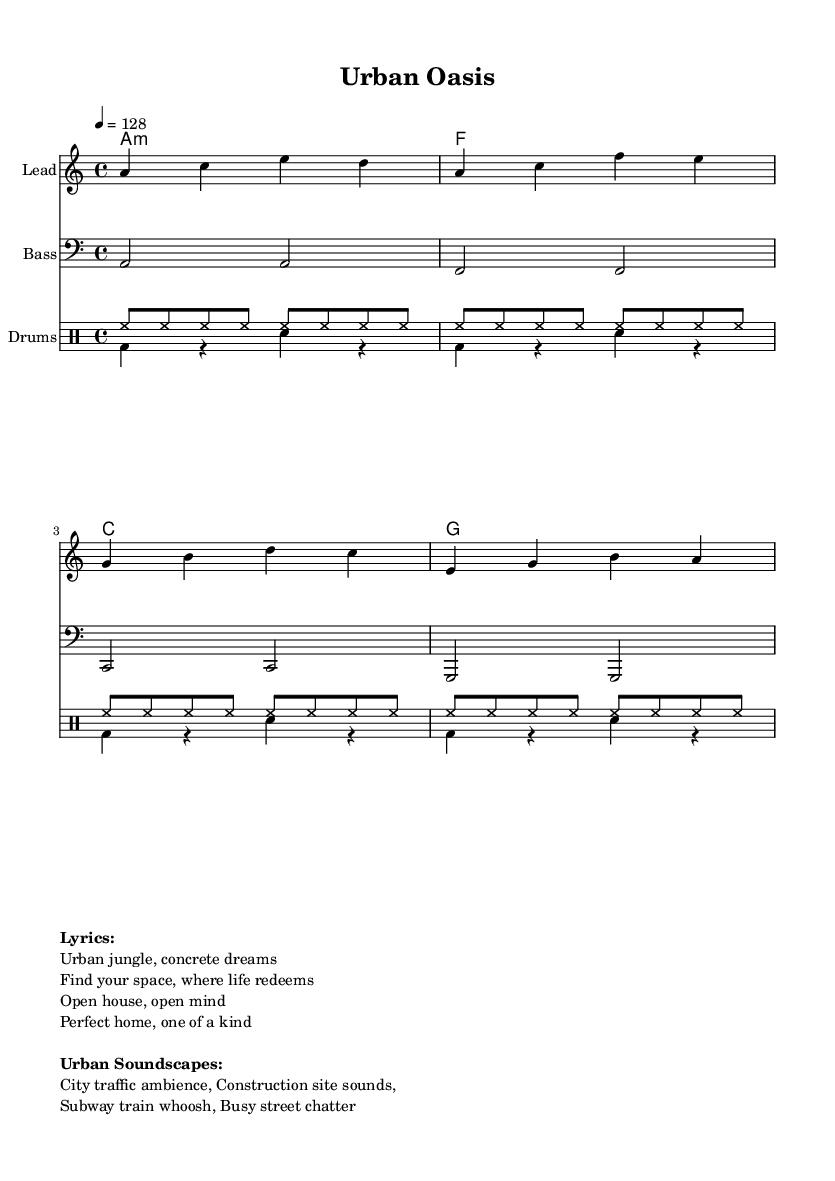What is the key signature of this music? The key signature is A minor, which can be identified by the absence of sharps or flats in the key signature section.
Answer: A minor What is the time signature of this music? The time signature is indicated at the beginning of the score and is notated as 4/4, which means there are four beats in each measure.
Answer: 4/4 What is the tempo of this piece? The tempo is marked as quarter note equals 128 beats per minute, which is stated in the tempo instruction at the start of the score.
Answer: 128 How many measures are in the melody section? By counting the phrases in the melody provided, there are four measures total, as indicated by the respective bar lines.
Answer: 4 Which instrument plays the bass line? The bass line is typically played by a bass instrument, which is identified as "Bass" in the staff heading of the bass section.
Answer: Bass What type of drum sounds are represented in the drummode? The drummode consists of hi-hat (hh) and bass drum (bd) sounds, indicated by their respective notation in the drum sections.
Answer: Hi-hat and bass drum What is the theme of the lyrics? The theme of the lyrics revolves around real estate and finding a perfect home amidst urban life, capturing the essence of the song's title "Urban Oasis."
Answer: Real estate theme 